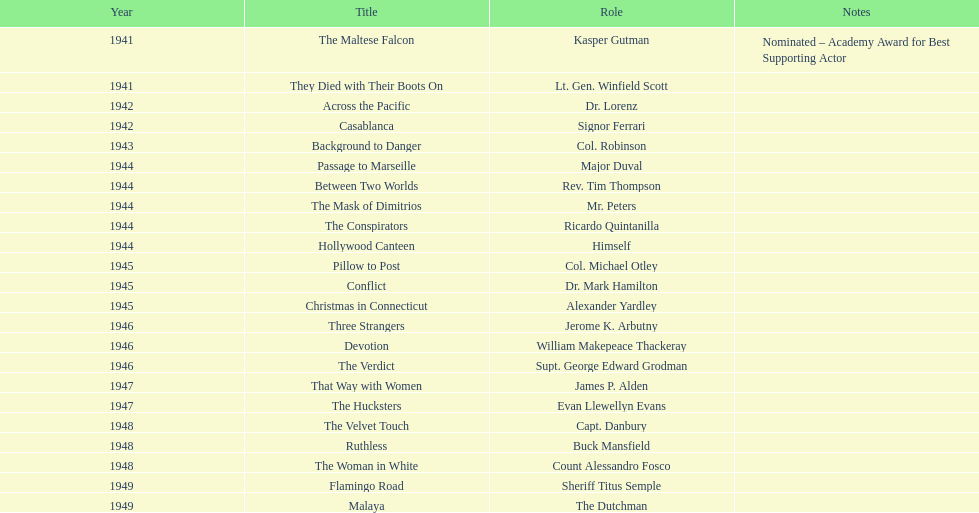What were the first and last movies greenstreet acted in? The Maltese Falcon, Malaya. 